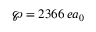Convert formula to latex. <formula><loc_0><loc_0><loc_500><loc_500>\wp = 2 3 6 6 \, e a _ { 0 }</formula> 